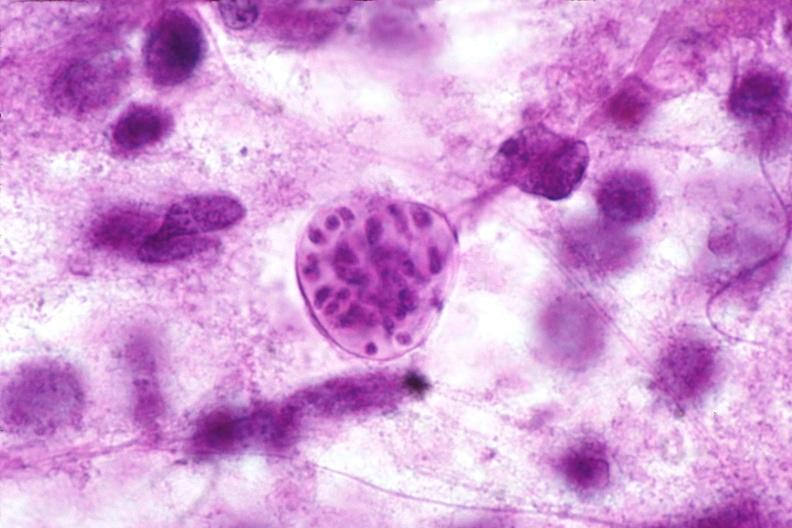does this image show brain, toxoplasma encephalitis?
Answer the question using a single word or phrase. Yes 